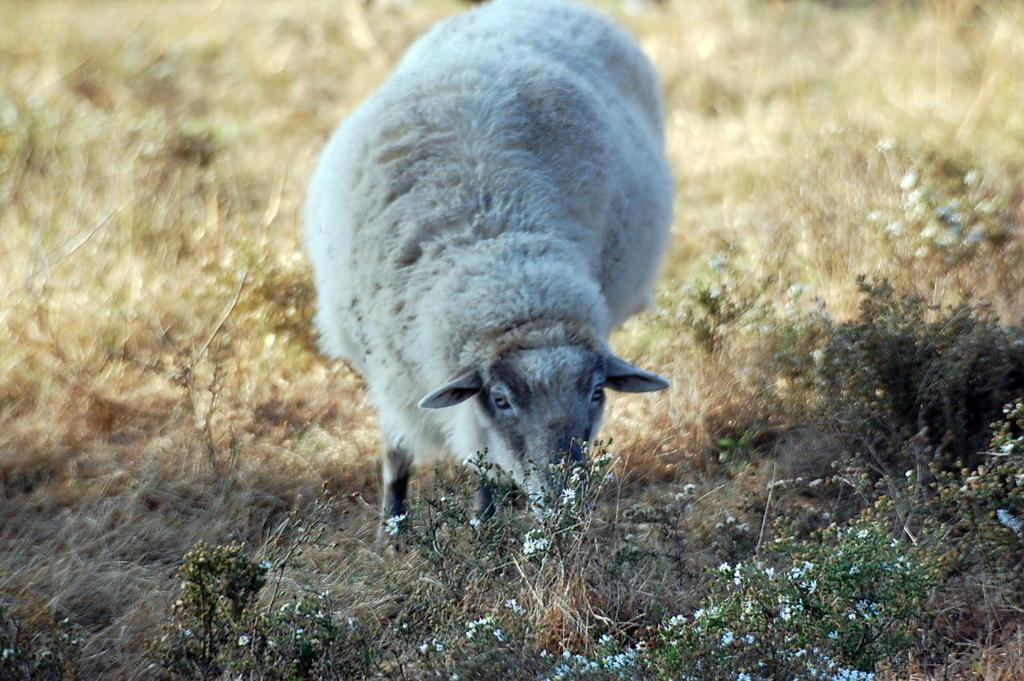What type of animal is present in the image? There is a white color sheep in the image. What is the ground covered with in the image? There is grass on the ground in the image. What type of badge can be seen on the sheep in the image? There is no badge present on the sheep in the image. Is there a bomb visible in the image? There is no bomb present in the image. 